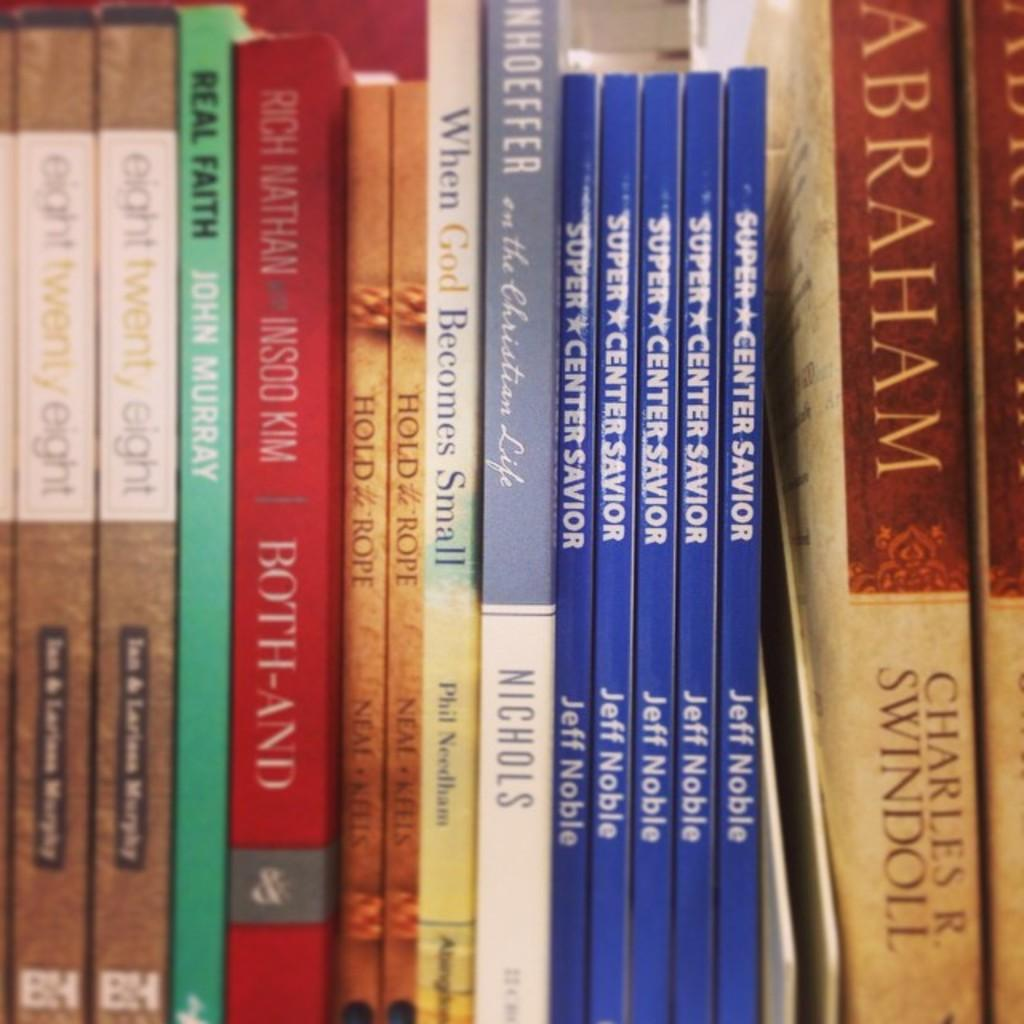<image>
Provide a brief description of the given image. The title of the blue book is Super Center Savior 